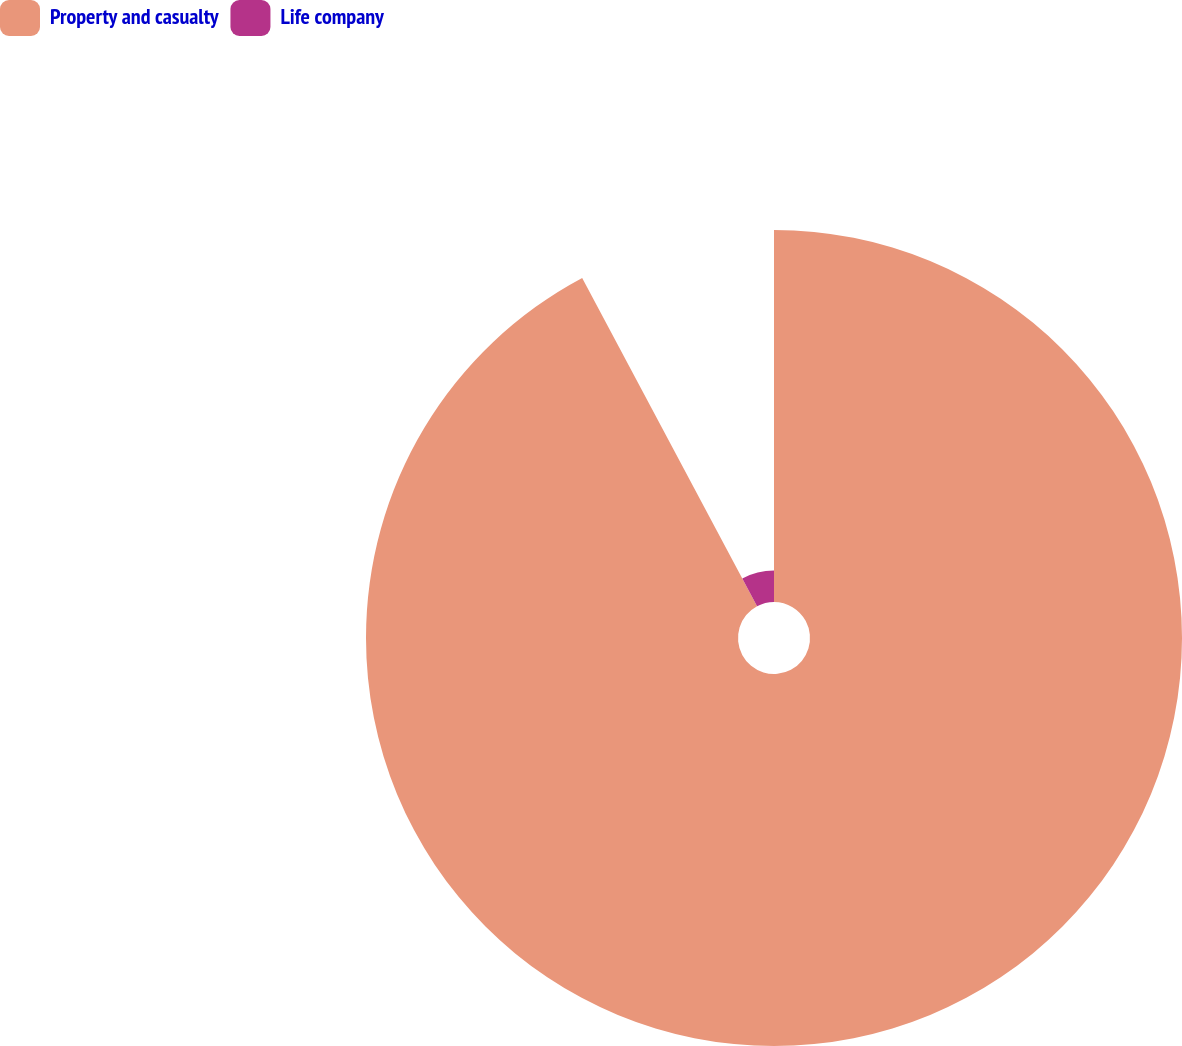Convert chart to OTSL. <chart><loc_0><loc_0><loc_500><loc_500><pie_chart><fcel>Property and casualty<fcel>Life company<nl><fcel>92.21%<fcel>7.79%<nl></chart> 